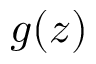<formula> <loc_0><loc_0><loc_500><loc_500>g ( z )</formula> 